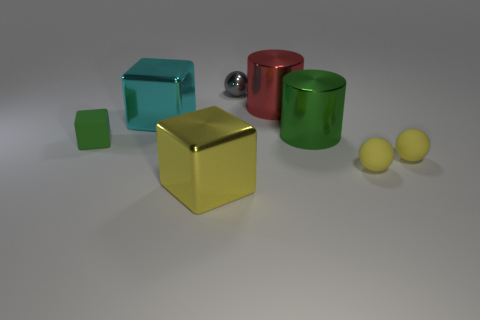What color is the other large cube that is the same material as the cyan block?
Give a very brief answer. Yellow. Do the big thing that is in front of the big green object and the sphere that is behind the green rubber thing have the same material?
Offer a very short reply. Yes. There is a cylinder that is the same color as the rubber cube; what is its size?
Your answer should be compact. Large. There is a tiny gray sphere that is to the left of the large red object; what material is it?
Provide a short and direct response. Metal. There is a big object in front of the small green object; does it have the same shape as the large cyan metallic thing that is right of the small block?
Your answer should be very brief. Yes. There is a big thing that is the same color as the tiny matte block; what is its material?
Ensure brevity in your answer.  Metal. Are there any large purple shiny blocks?
Your answer should be compact. No. What is the material of the red object that is the same shape as the big green object?
Provide a short and direct response. Metal. There is a small green thing; are there any green metal objects behind it?
Your response must be concise. Yes. Is the material of the tiny sphere behind the green rubber block the same as the cyan cube?
Your answer should be compact. Yes. 